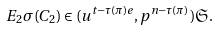Convert formula to latex. <formula><loc_0><loc_0><loc_500><loc_500>E _ { 2 } \sigma ( C _ { 2 } ) \in ( u ^ { t - \tau ( \pi ) e } , p ^ { n - \tau ( \pi ) } ) \mathfrak { S } .</formula> 